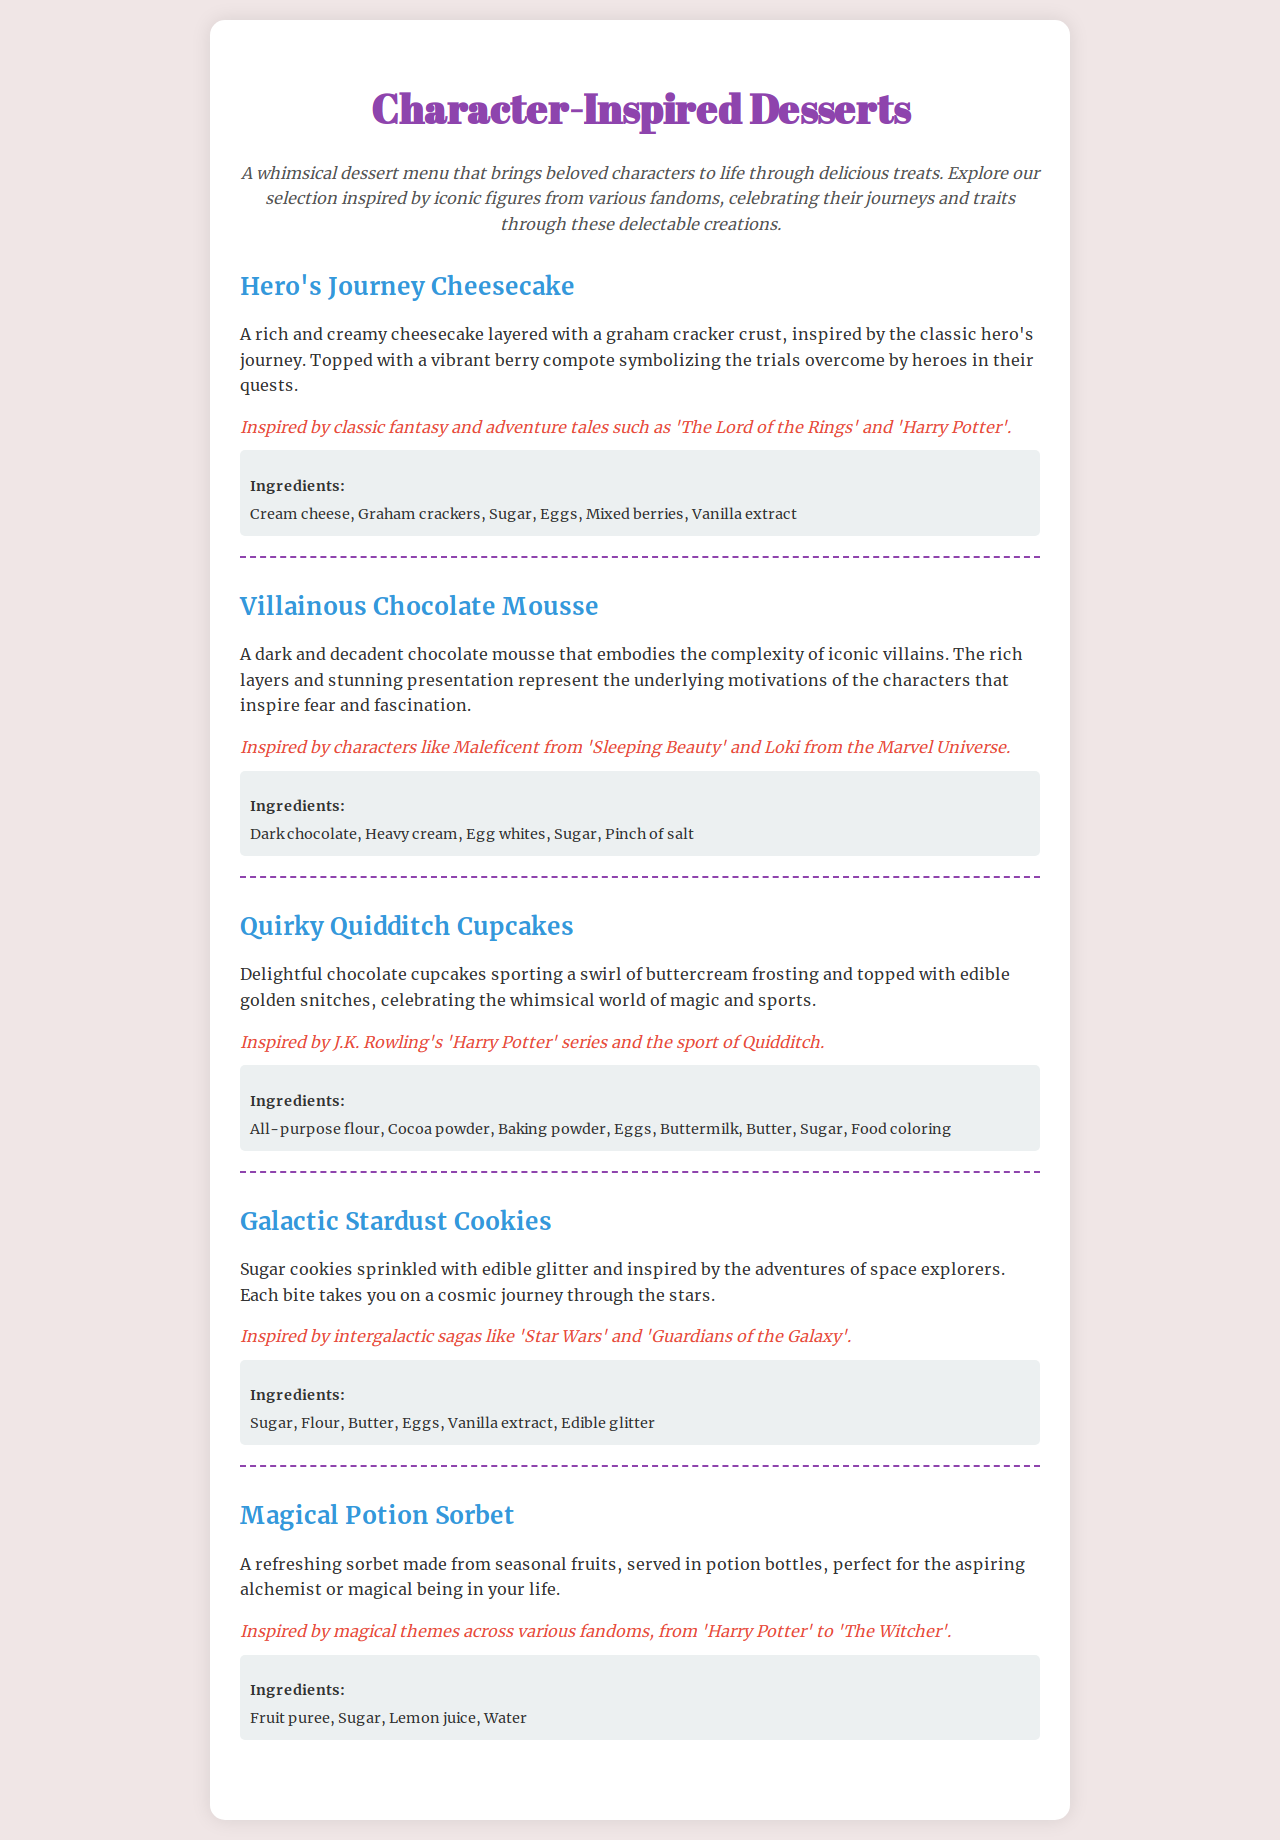What dessert is inspired by heroes? The dessert inspired by heroes is the "Hero's Journey Cheesecake."
Answer: Hero's Journey Cheesecake What is the main ingredient in Villainous Chocolate Mousse? The main ingredient in Villainous Chocolate Mousse is Dark chocolate.
Answer: Dark chocolate How many desserts are featured in the menu? There are five desserts featured in the menu.
Answer: Five Which dessert features edible glitter? The dessert that features edible glitter is the "Galactic Stardust Cookies."
Answer: Galactic Stardust Cookies What fruit-based dessert is mentioned? The fruit-based dessert mentioned is the "Magical Potion Sorbet."
Answer: Magical Potion Sorbet Which fandom is associated with Quirky Quidditch Cupcakes? The fandom associated with Quirky Quidditch Cupcakes is J.K. Rowling's 'Harry Potter' series.
Answer: J.K. Rowling's 'Harry Potter' series What type of frosting is used on the cupcakes? The type of frosting used on the cupcakes is buttercream frosting.
Answer: Buttercream frosting What theme inspires the Magical Potion Sorbet? The theme that inspires the Magical Potion Sorbet is magical themes.
Answer: Magical themes 